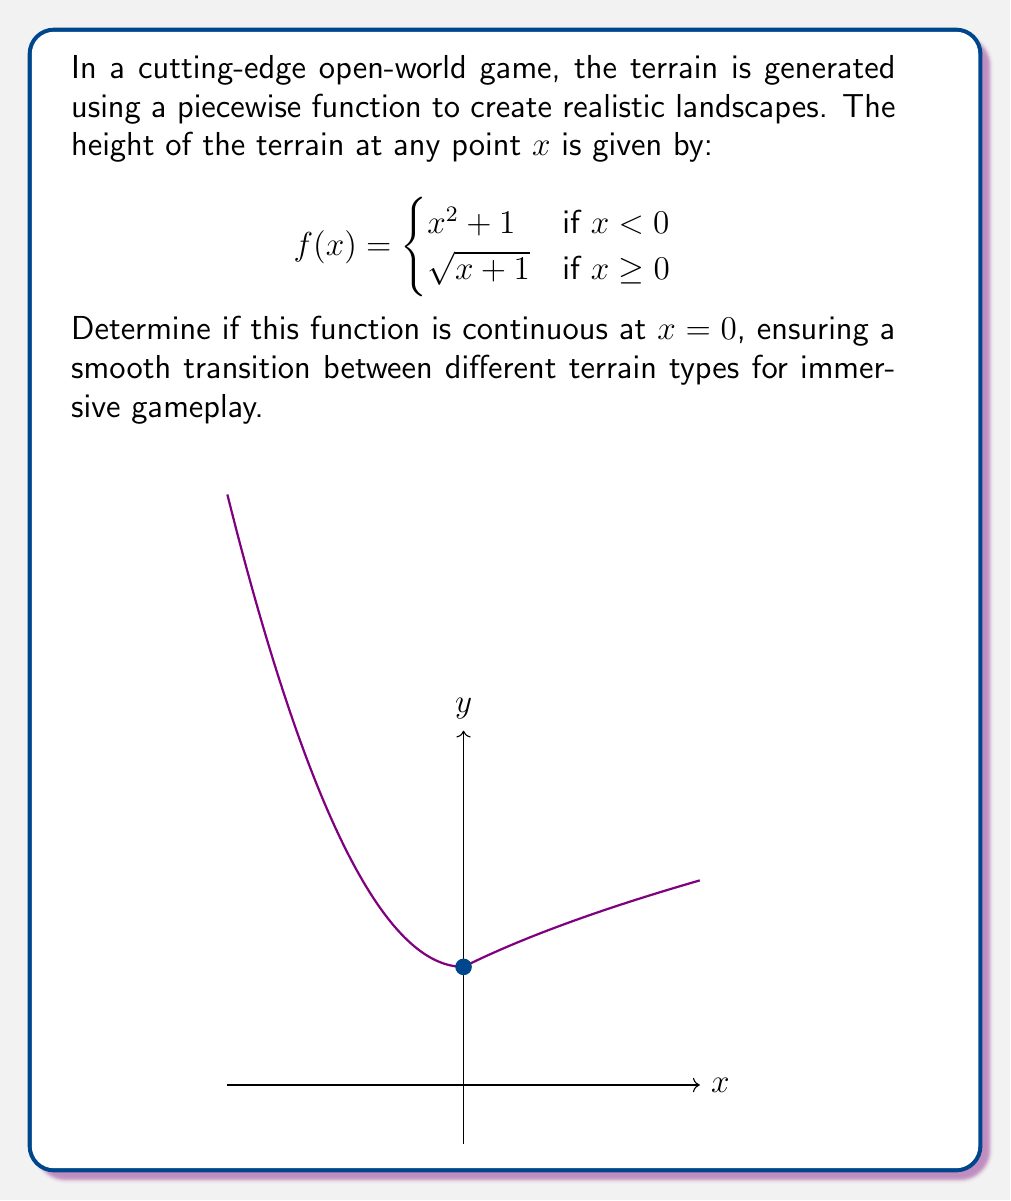Help me with this question. To determine if the function is continuous at x = 0, we need to check three conditions:

1. $f(0^-)$ exists (left-hand limit)
2. $f(0^+)$ exists (right-hand limit)
3. $f(0^-) = f(0^+) = f(0)$

Step 1: Calculate $f(0^-)$
$$\lim_{x \to 0^-} f(x) = \lim_{x \to 0^-} (x^2 + 1) = 0^2 + 1 = 1$$

Step 2: Calculate $f(0^+)$
$$\lim_{x \to 0^+} f(x) = \lim_{x \to 0^+} \sqrt{x + 1} = \sqrt{0 + 1} = 1$$

Step 3: Calculate $f(0)$
Since x = 0 falls into the second piece of the function (x ≥ 0):
$$f(0) = \sqrt{0 + 1} = 1$$

Step 4: Check if all three conditions are met
1. $f(0^-) = 1$ (exists)
2. $f(0^+) = 1$ (exists)
3. $f(0^-) = f(0^+) = f(0) = 1$

Since all three conditions are satisfied, the function is continuous at x = 0.
Answer: The function is continuous at x = 0. 